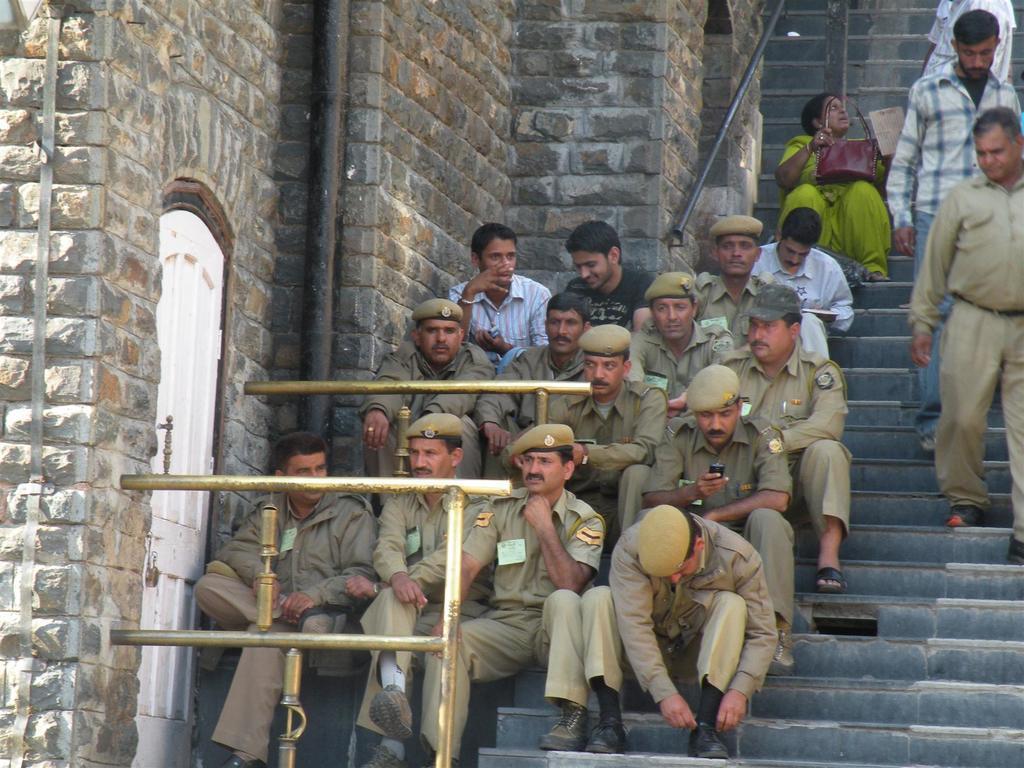Please provide a concise description of this image. In this image we can see a group of people sitting on the stairs. We can also see some people walking downstairs. On the left side we can see a door, pole and a wall with stones. 